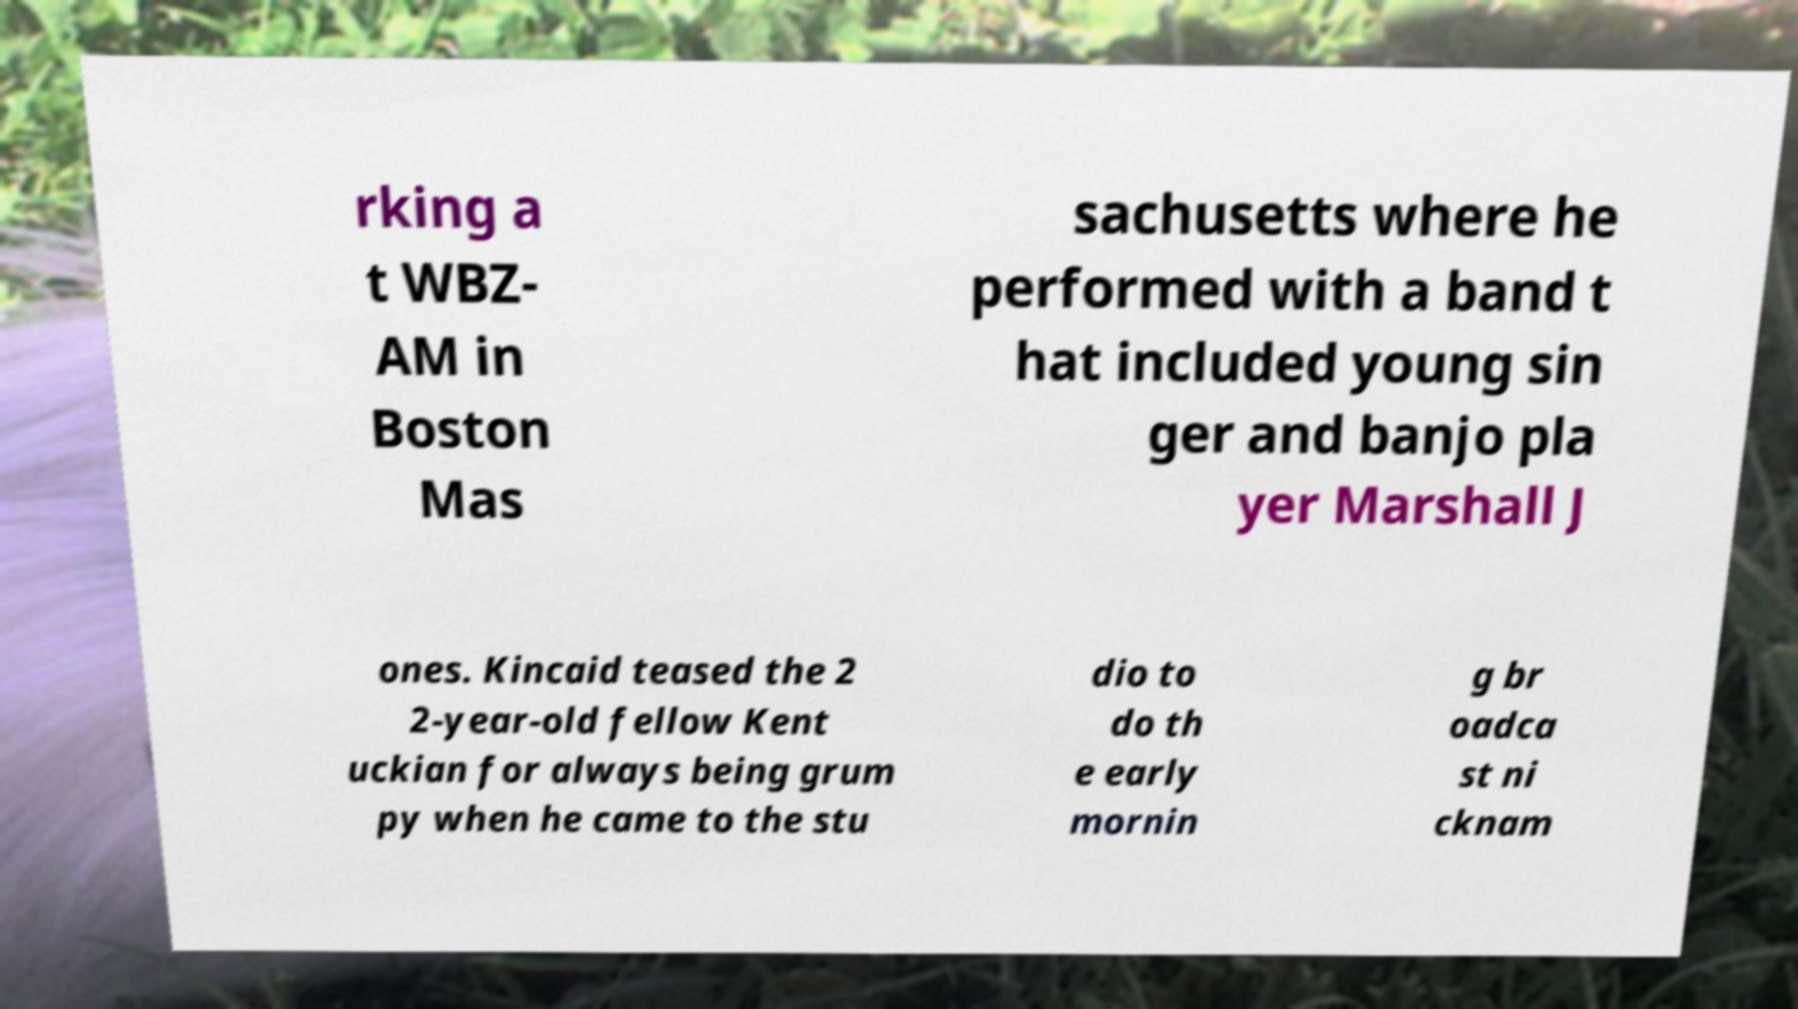What messages or text are displayed in this image? I need them in a readable, typed format. rking a t WBZ- AM in Boston Mas sachusetts where he performed with a band t hat included young sin ger and banjo pla yer Marshall J ones. Kincaid teased the 2 2-year-old fellow Kent uckian for always being grum py when he came to the stu dio to do th e early mornin g br oadca st ni cknam 